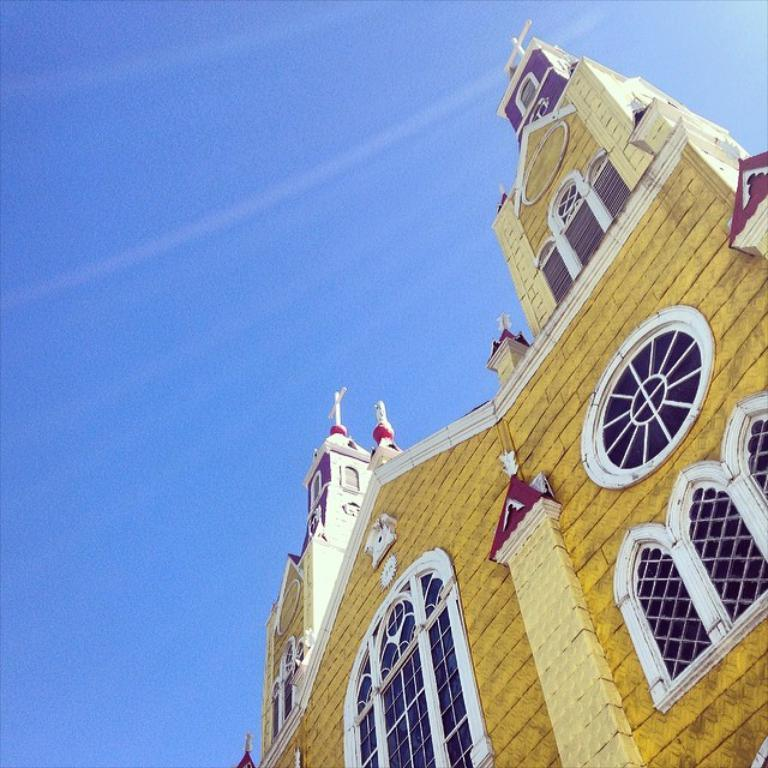What is the main subject of the picture? The main subject of the picture is a building. What specific features can be seen on the building? The building has windows. What can be seen in the background of the picture? The sky is visible in the background of the picture. What color is the orange that is being peeled on the street in the image? There is no orange or street present in the image; it only features a building and the sky. 